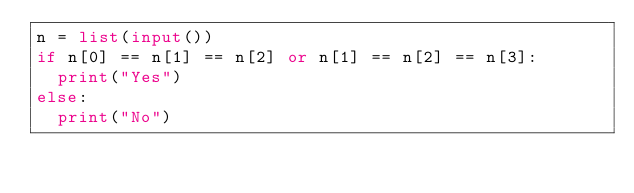Convert code to text. <code><loc_0><loc_0><loc_500><loc_500><_Python_>n = list(input())
if n[0] == n[1] == n[2] or n[1] == n[2] == n[3]:
  print("Yes")
else:
  print("No")</code> 